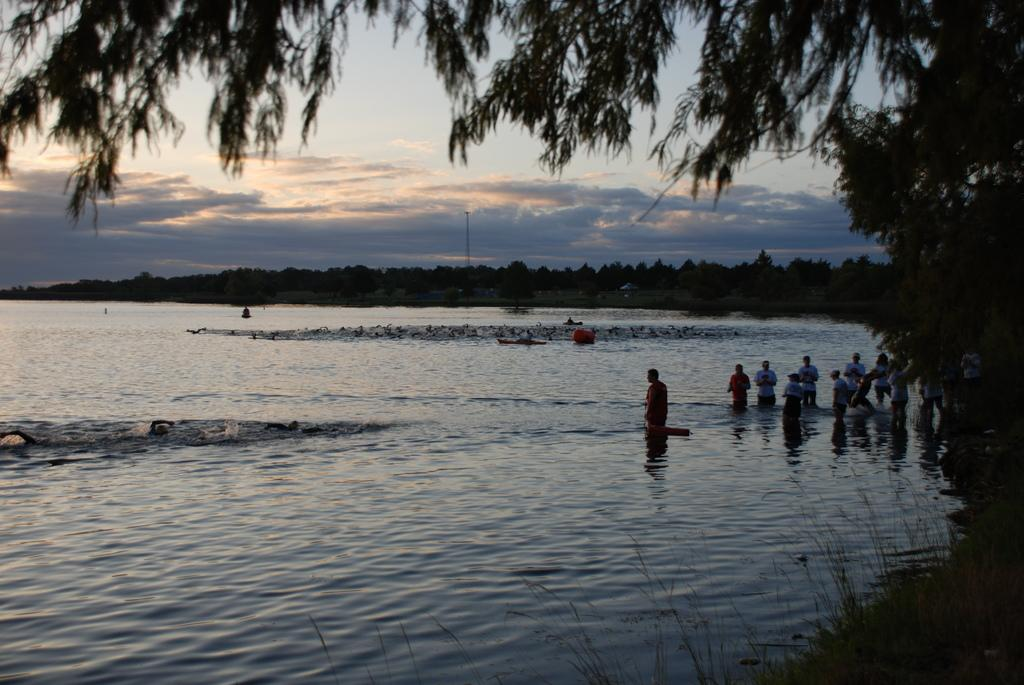What are the people in the image doing? The people in the image are in the water. What type of vegetation can be seen in the image? There are trees and grass in the image. What objects are present in the water? There are boats in the water. What is the pole used for in the image? The purpose of the pole is not specified in the image. What is visible in the background of the image? The sky is visible in the background, and clouds are present in the sky. What type of nut is being used to hold the books together in the image? There are no nuts or books present in the image; it features people in the water, trees, grass, boats, a pole, and a sky with clouds. 